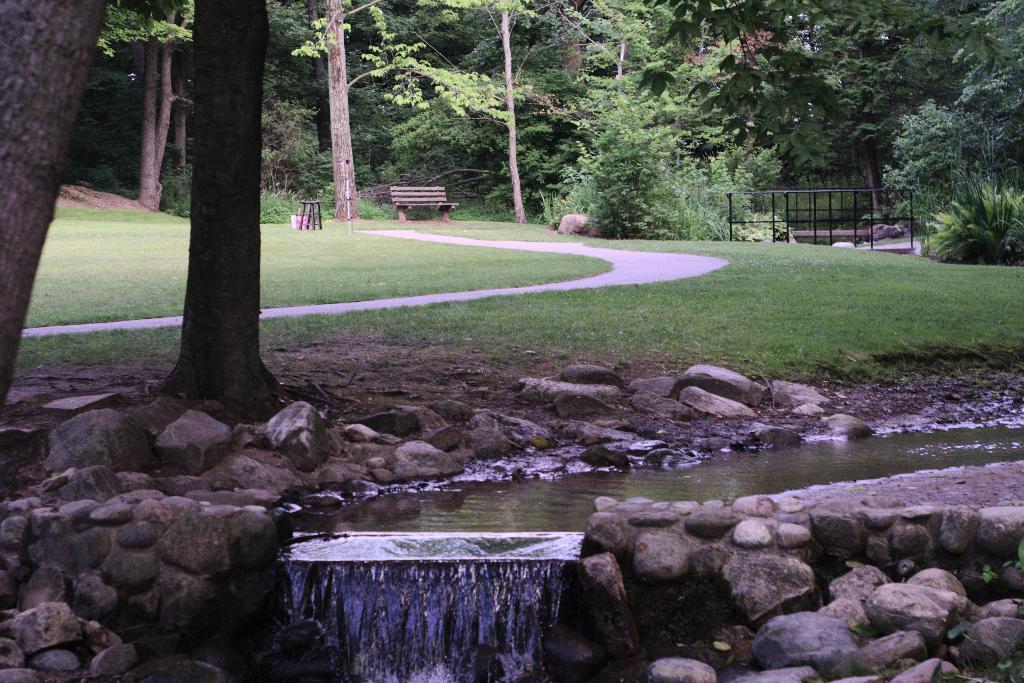Please provide a concise description of this image. In this image we can see water stream. To the both sides of the water stream, stones are there. We can see grassy land and trees in the middle of the image. There are trees, bench and fencing at the top of the image. 